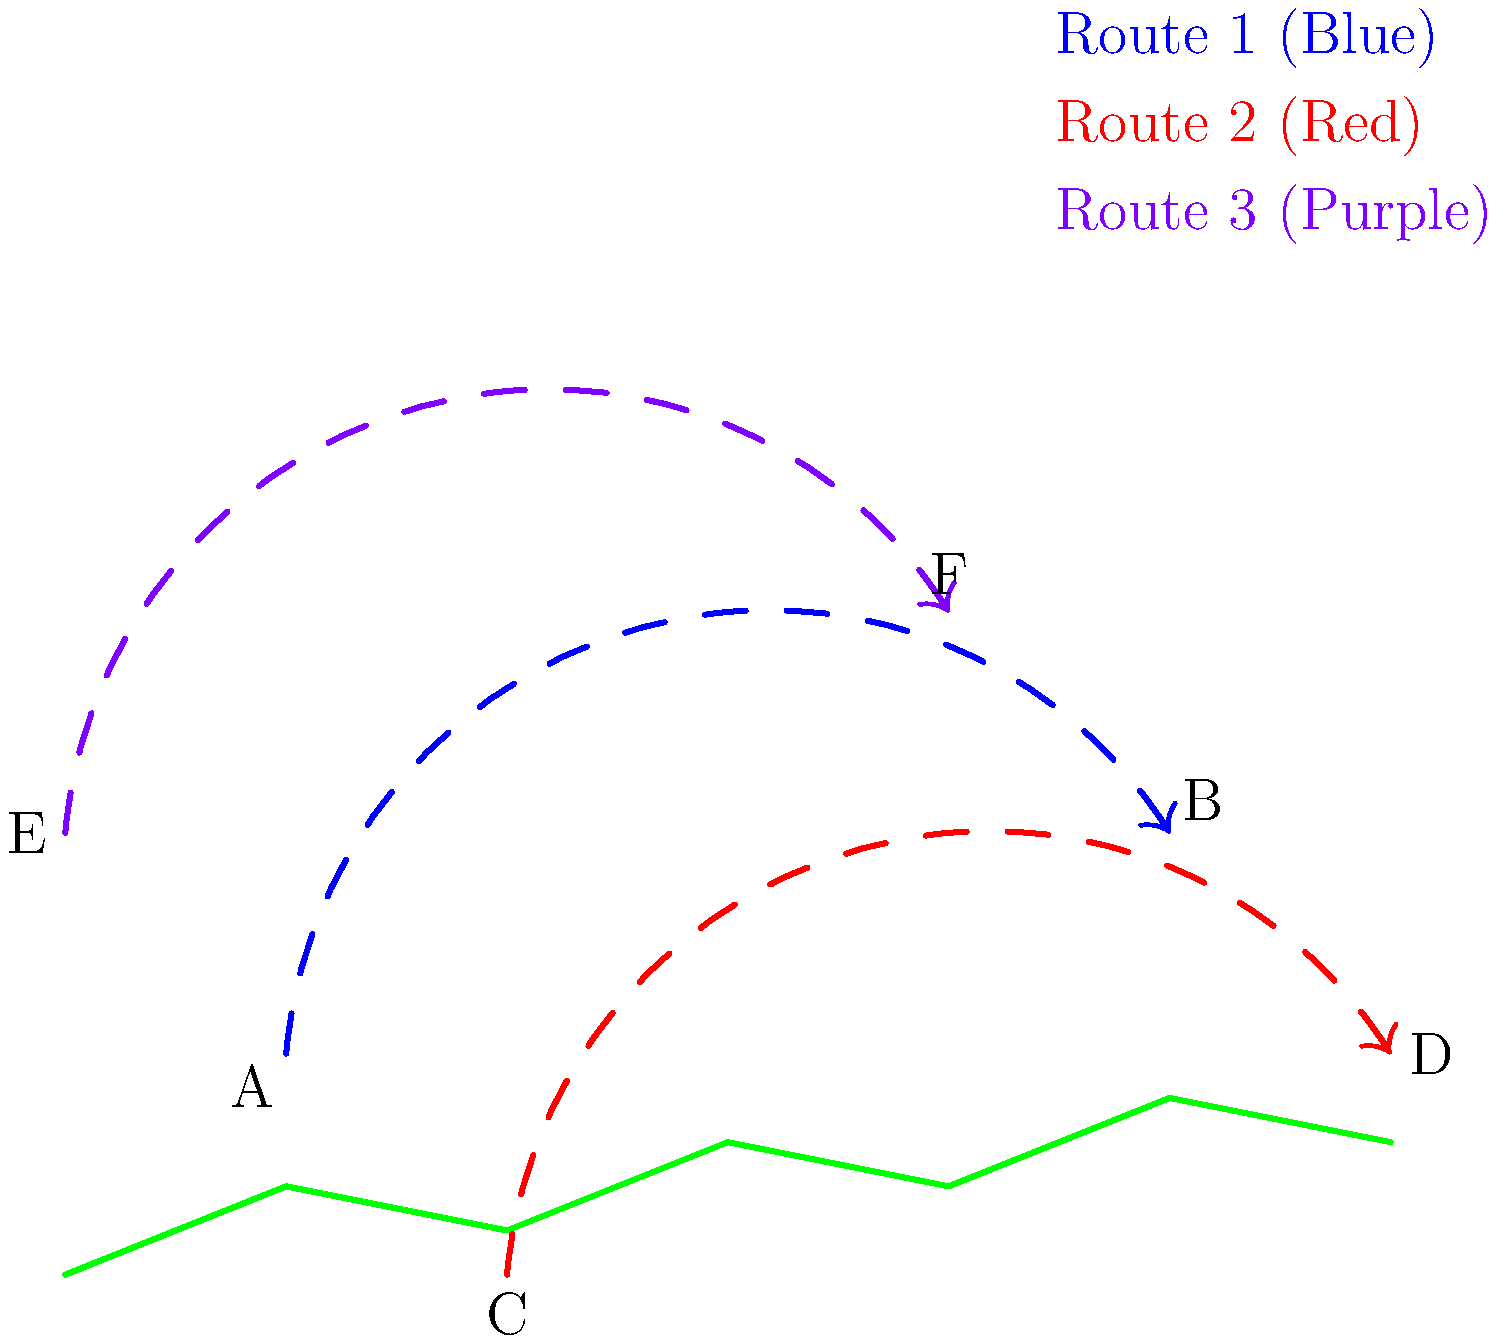Based on the map showing the migration routes of aquatic birds in the Amazon basin, which route covers the longest distance and likely represents the migration path of a long-distance migratory species? To determine which route covers the longest distance, we need to analyze each path:

1. Route 1 (Blue): From point A to point B
   - Travels from southwest to northeast
   - Covers a moderate diagonal distance across the basin

2. Route 2 (Red): From point C to point D
   - Travels from south to north, then curves slightly southeast
   - Covers a long distance, spanning almost the entire width of the basin

3. Route 3 (Purple): From point E to point F
   - Travels from west to east, with a northward curve in the middle
   - Covers a significant distance, but not as extensive as Route 2

Comparing these routes:
- Route 2 (Red) appears to cover the longest distance, stretching across the entire width of the Amazon basin.
- It also has the most pronounced curve, indicating a complex migration pattern.
- Long-distance migratory species often have more extensive and complex migration routes to take advantage of seasonal resources and breeding grounds.

Therefore, Route 2 (Red) is likely to represent the migration path of a long-distance migratory species due to its length and complexity.
Answer: Route 2 (Red) 